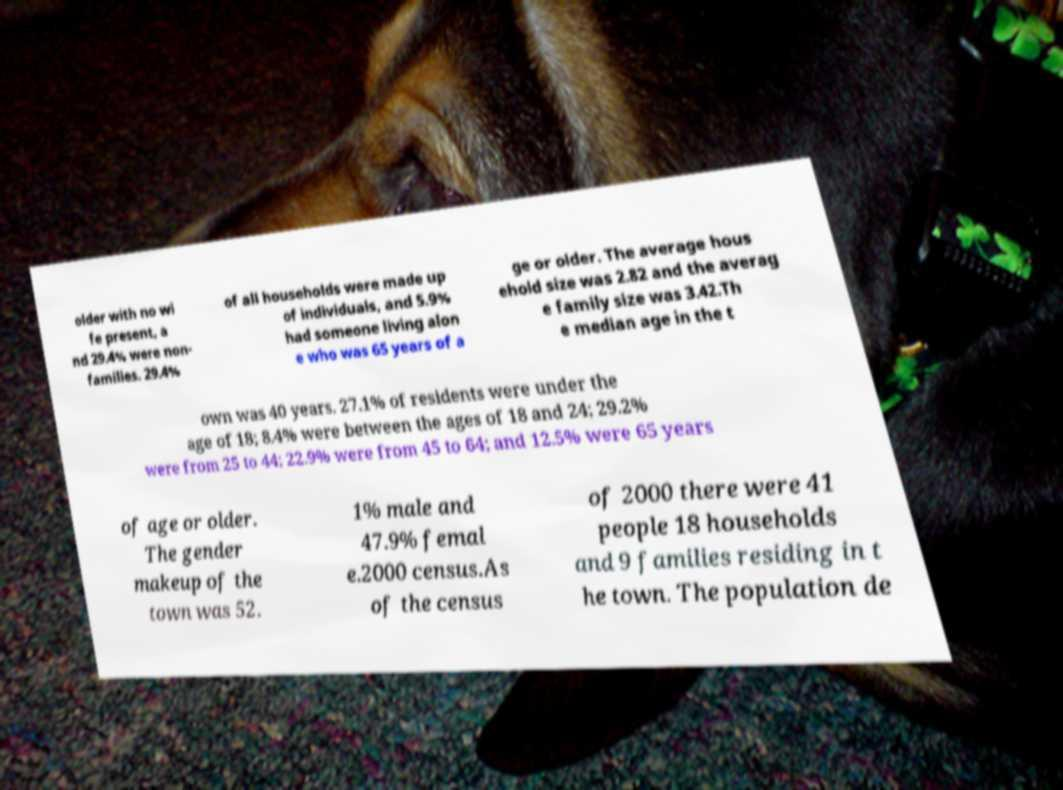Could you extract and type out the text from this image? older with no wi fe present, a nd 29.4% were non- families. 29.4% of all households were made up of individuals, and 5.9% had someone living alon e who was 65 years of a ge or older. The average hous ehold size was 2.82 and the averag e family size was 3.42.Th e median age in the t own was 40 years. 27.1% of residents were under the age of 18; 8.4% were between the ages of 18 and 24; 29.2% were from 25 to 44; 22.9% were from 45 to 64; and 12.5% were 65 years of age or older. The gender makeup of the town was 52. 1% male and 47.9% femal e.2000 census.As of the census of 2000 there were 41 people 18 households and 9 families residing in t he town. The population de 